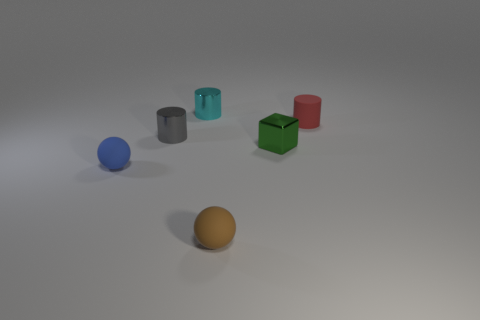Can you infer the possible purpose of this arrangement? Given the simplicity and the deliberate spacing between the objects, this arrangement might be part of a visual study or composition exercise, possibly meant to illustrate concepts such as color, form, shadow, and spacing for educational or demonstrative purposes. 